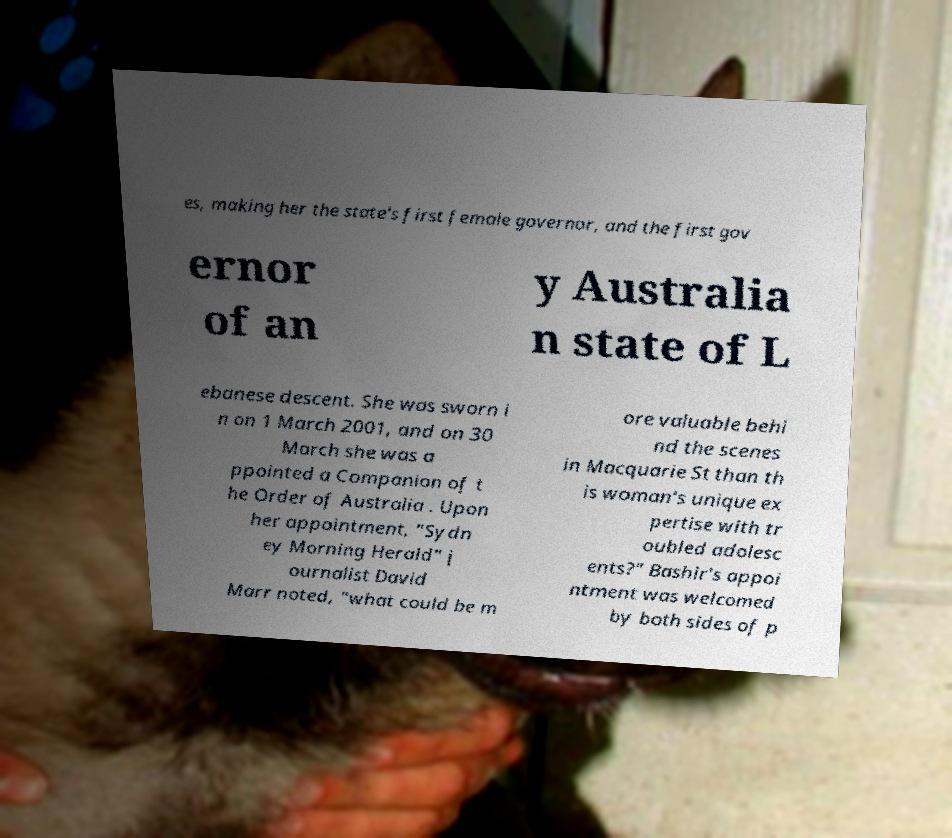Could you extract and type out the text from this image? es, making her the state's first female governor, and the first gov ernor of an y Australia n state of L ebanese descent. She was sworn i n on 1 March 2001, and on 30 March she was a ppointed a Companion of t he Order of Australia . Upon her appointment, "Sydn ey Morning Herald" j ournalist David Marr noted, "what could be m ore valuable behi nd the scenes in Macquarie St than th is woman's unique ex pertise with tr oubled adolesc ents?" Bashir's appoi ntment was welcomed by both sides of p 